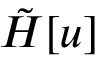<formula> <loc_0><loc_0><loc_500><loc_500>\tilde { H } [ u ]</formula> 